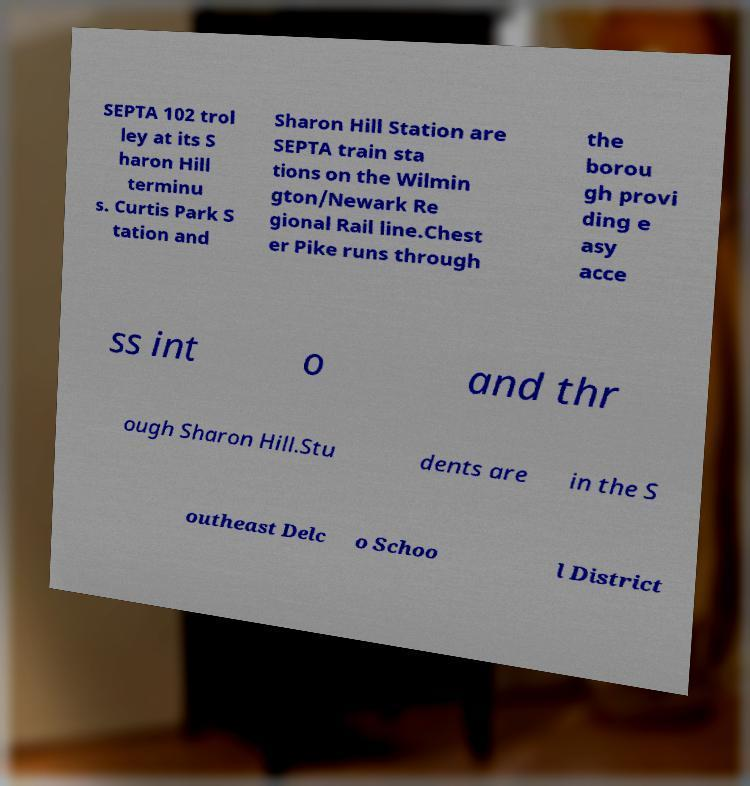Can you read and provide the text displayed in the image?This photo seems to have some interesting text. Can you extract and type it out for me? SEPTA 102 trol ley at its S haron Hill terminu s. Curtis Park S tation and Sharon Hill Station are SEPTA train sta tions on the Wilmin gton/Newark Re gional Rail line.Chest er Pike runs through the borou gh provi ding e asy acce ss int o and thr ough Sharon Hill.Stu dents are in the S outheast Delc o Schoo l District 